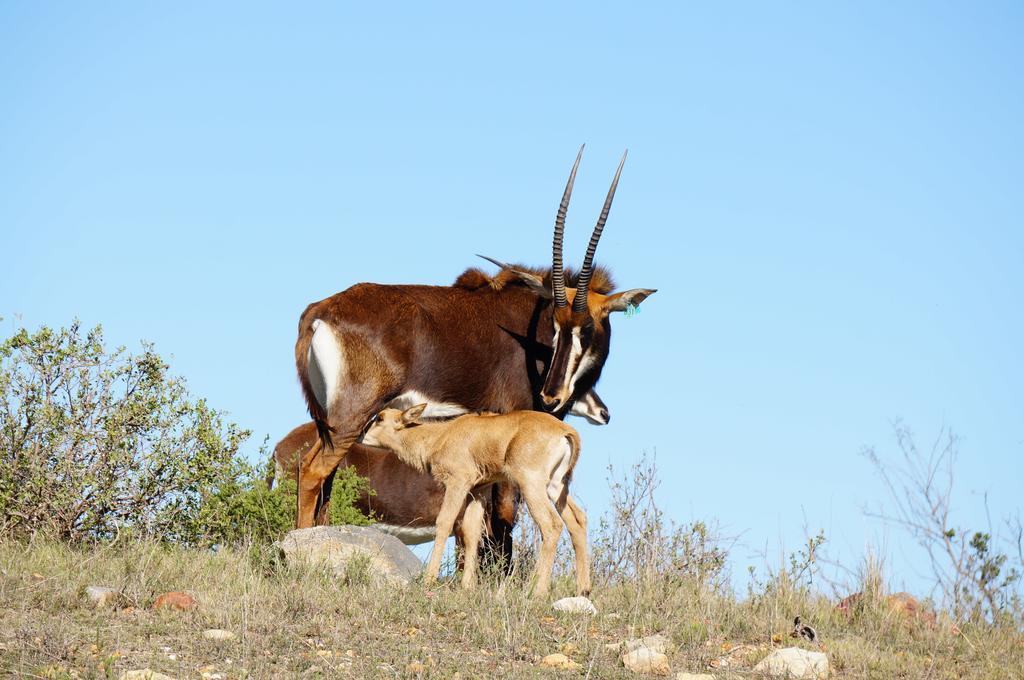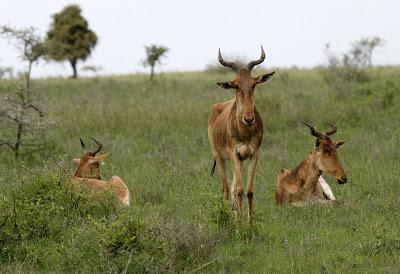The first image is the image on the left, the second image is the image on the right. Given the left and right images, does the statement "One of the images shows exactly one antelope." hold true? Answer yes or no. No. 